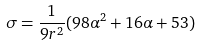<formula> <loc_0><loc_0><loc_500><loc_500>\sigma = \frac { 1 } { 9 r ^ { 2 } } ( 9 8 \alpha ^ { 2 } + 1 6 \alpha + 5 3 )</formula> 